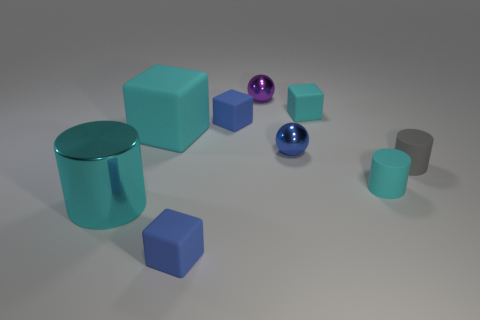Subtract all cyan cylinders. How many were subtracted if there are1cyan cylinders left? 1 Subtract all balls. How many objects are left? 7 Subtract 2 cylinders. How many cylinders are left? 1 Subtract all cyan spheres. Subtract all purple cylinders. How many spheres are left? 2 Subtract all gray cylinders. How many blue spheres are left? 1 Subtract all tiny gray rubber objects. Subtract all tiny brown metallic objects. How many objects are left? 8 Add 2 large matte objects. How many large matte objects are left? 3 Add 3 big gray rubber things. How many big gray rubber things exist? 3 Add 1 tiny cyan cylinders. How many objects exist? 10 Subtract all gray cylinders. How many cylinders are left? 2 